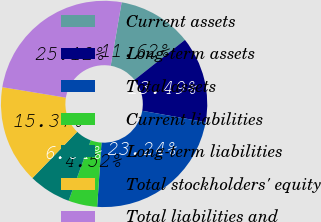Convert chart to OTSL. <chart><loc_0><loc_0><loc_500><loc_500><pie_chart><fcel>Current assets<fcel>Long-term assets<fcel>Total assets<fcel>Current liabilities<fcel>Long-term liabilities<fcel>Total stockholders' equity<fcel>Total liabilities and<nl><fcel>11.62%<fcel>13.49%<fcel>23.24%<fcel>4.52%<fcel>6.64%<fcel>15.37%<fcel>25.12%<nl></chart> 